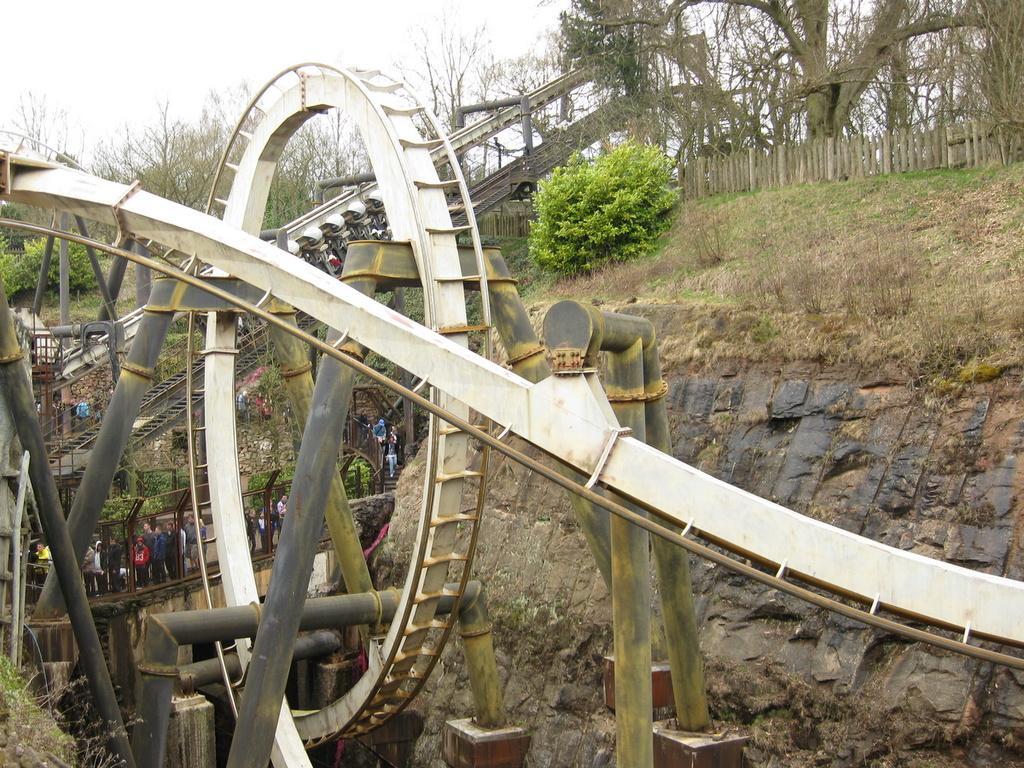Can you describe this image briefly? In this image we can see a roller coaster, persons standing on the bridge, hills, bushes, fence, trees and sky. 